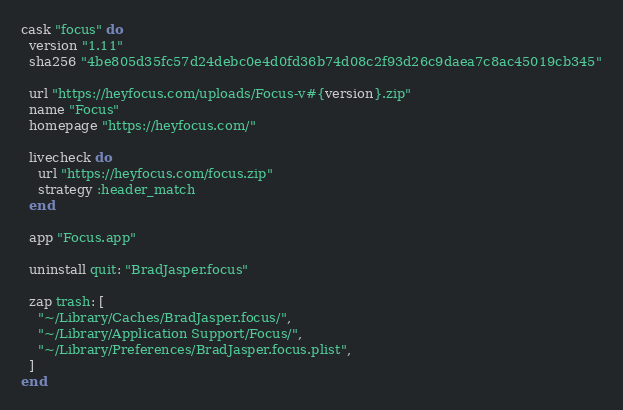<code> <loc_0><loc_0><loc_500><loc_500><_Ruby_>cask "focus" do
  version "1.11"
  sha256 "4be805d35fc57d24debc0e4d0fd36b74d08c2f93d26c9daea7c8ac45019cb345"

  url "https://heyfocus.com/uploads/Focus-v#{version}.zip"
  name "Focus"
  homepage "https://heyfocus.com/"

  livecheck do
    url "https://heyfocus.com/focus.zip"
    strategy :header_match
  end

  app "Focus.app"

  uninstall quit: "BradJasper.focus"

  zap trash: [
    "~/Library/Caches/BradJasper.focus/",
    "~/Library/Application Support/Focus/",
    "~/Library/Preferences/BradJasper.focus.plist",
  ]
end
</code> 